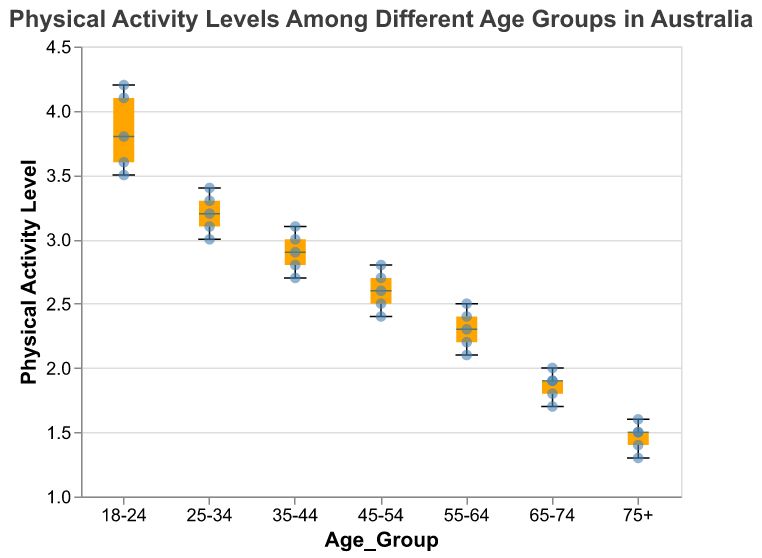How many age groups are displayed in the figure? There are 7 distinct categories on the x-axis, each representing a different age group: 18-24, 25-34, 35-44, 45-54, 55-64, 65-74, and 75+.
Answer: 7 Which age group has the highest median physical activity level? The median value is indicated by the horizontal line inside each box plot. The 18-24 age group has the highest median, which is around 3.8.
Answer: 18-24 What is the range of physical activity levels for the 45-54 age group? The range is the difference between the maximum and minimum values within the whiskers of the box plot for the age group 45-54. The maximum value is 2.8, and the minimum value is 2.4, so the range is 2.8 - 2.4 = 0.4.
Answer: 0.4 Which age group shows the widest spread in physical activity levels? To determine the spread, look at the height of the box and the length of the whiskers. The 18-24 age group has the highest spread from around 3.5 to 4.2, indicating a wider spread compared to other age groups.
Answer: 18-24 What is the interquartile range (IQR) for the 25-34 age group? The IQR is the range between the first quartile (Q1) and the third quartile (Q3) of the box plot. The approximate Q1 value for the 25-34 age group is 3.1, and the approximate Q3 value is 3.3, so the IQR is 3.3 - 3.1 = 0.2.
Answer: 0.2 How does the physical activity level distribution change as age increases? By examining the box plots, as age increases, the median and overall physical activity levels tend to decrease, indicating that older age groups generally have lower physical activity levels.
Answer: Decreases Which age group has the lowest outlier in terms of physical activity level? Outliers are the points beyond the whiskers of the box plot. The lowest outlier is within the 75+ age group with a value of 1.3.
Answer: 75+ What is the median physical activity level for the 55-64 age group? The median is the line inside the box plot for 55-64, which is approximately at 2.3.
Answer: 2.3 Compare the physical activity levels of the age groups 35-44 and 45-54. Which one has higher levels? By comparing the medians of both age groups, 35-44 has a median around 2.9, and 45-54 has a median around 2.6. Therefore, 35-44 has higher physical activity levels.
Answer: 35-44 How are the individual data points (scatter points) distributed in the 65-74 age group? The individual data points for the 65-74 age group are mostly centered around physical activity levels of 1.8 to 2.0, with slight deviations below and above this range.
Answer: Around 1.8 to 2.0 